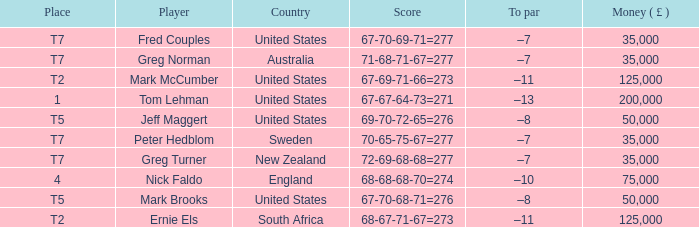What is To par, when Player is "Greg Turner"? –7. 